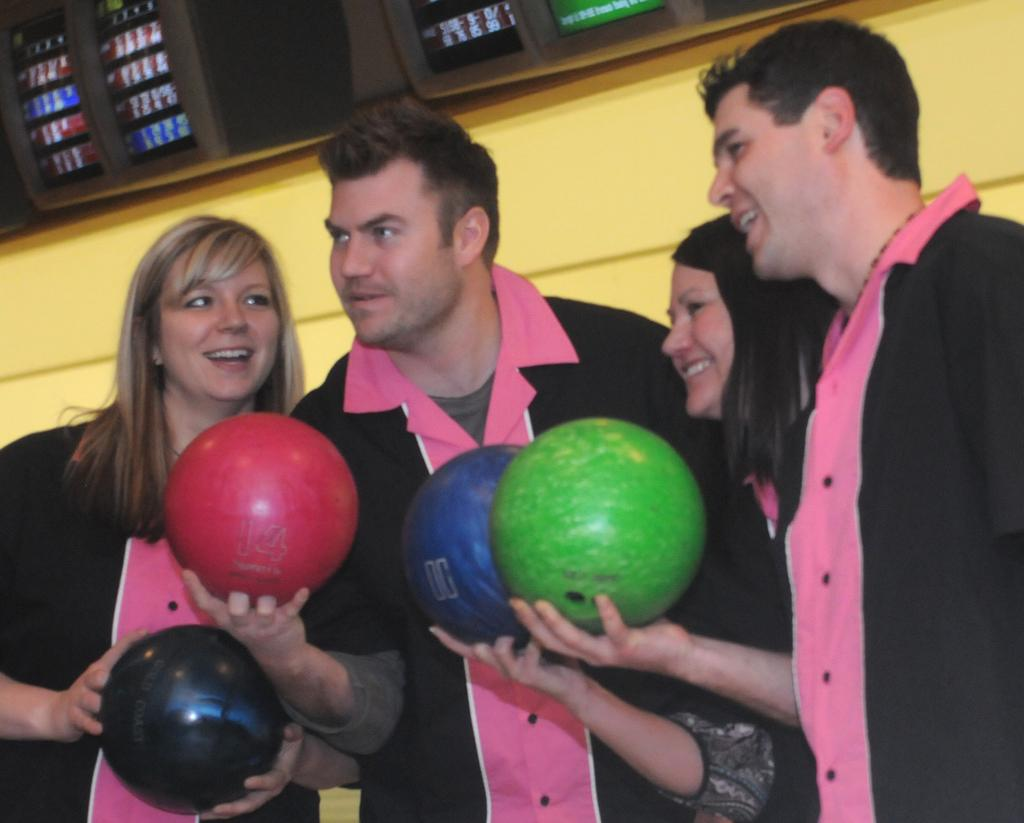What can be seen in the background of the image? There are screens and a wall visible in the background of the image. What are the people in the image holding? The people in the image are holding balls in their hands. What type of hearing is taking place in the image? There is no hearing present in the image; it features people holding balls in their hands. What type of frame surrounds the image? The question about the frame is irrelevant, as we are discussing the content of the image itself and not the physical characteristics of the image itself. 